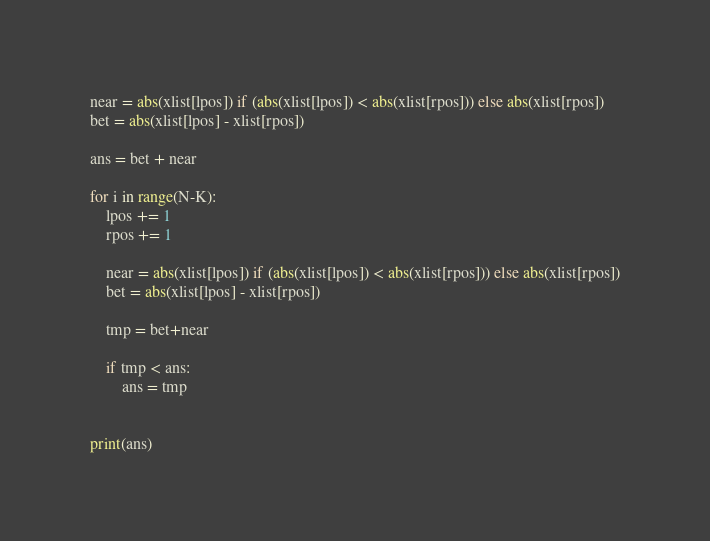<code> <loc_0><loc_0><loc_500><loc_500><_Python_>
near = abs(xlist[lpos]) if (abs(xlist[lpos]) < abs(xlist[rpos])) else abs(xlist[rpos])
bet = abs(xlist[lpos] - xlist[rpos])

ans = bet + near

for i in range(N-K):
    lpos += 1
    rpos += 1

    near = abs(xlist[lpos]) if (abs(xlist[lpos]) < abs(xlist[rpos])) else abs(xlist[rpos])
    bet = abs(xlist[lpos] - xlist[rpos])

    tmp = bet+near

    if tmp < ans:
        ans = tmp


print(ans)
</code> 